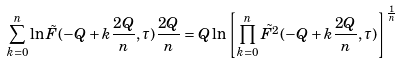Convert formula to latex. <formula><loc_0><loc_0><loc_500><loc_500>\sum _ { k = 0 } ^ { n } \ln \tilde { F } ( - Q + k \frac { 2 Q } { n } , \tau ) \frac { 2 Q } { n } = Q \ln \left [ \prod _ { k = 0 } ^ { n } \tilde { F ^ { 2 } } ( - Q + k \frac { 2 Q } { n } , \tau ) \right ] ^ { \frac { 1 } { n } }</formula> 